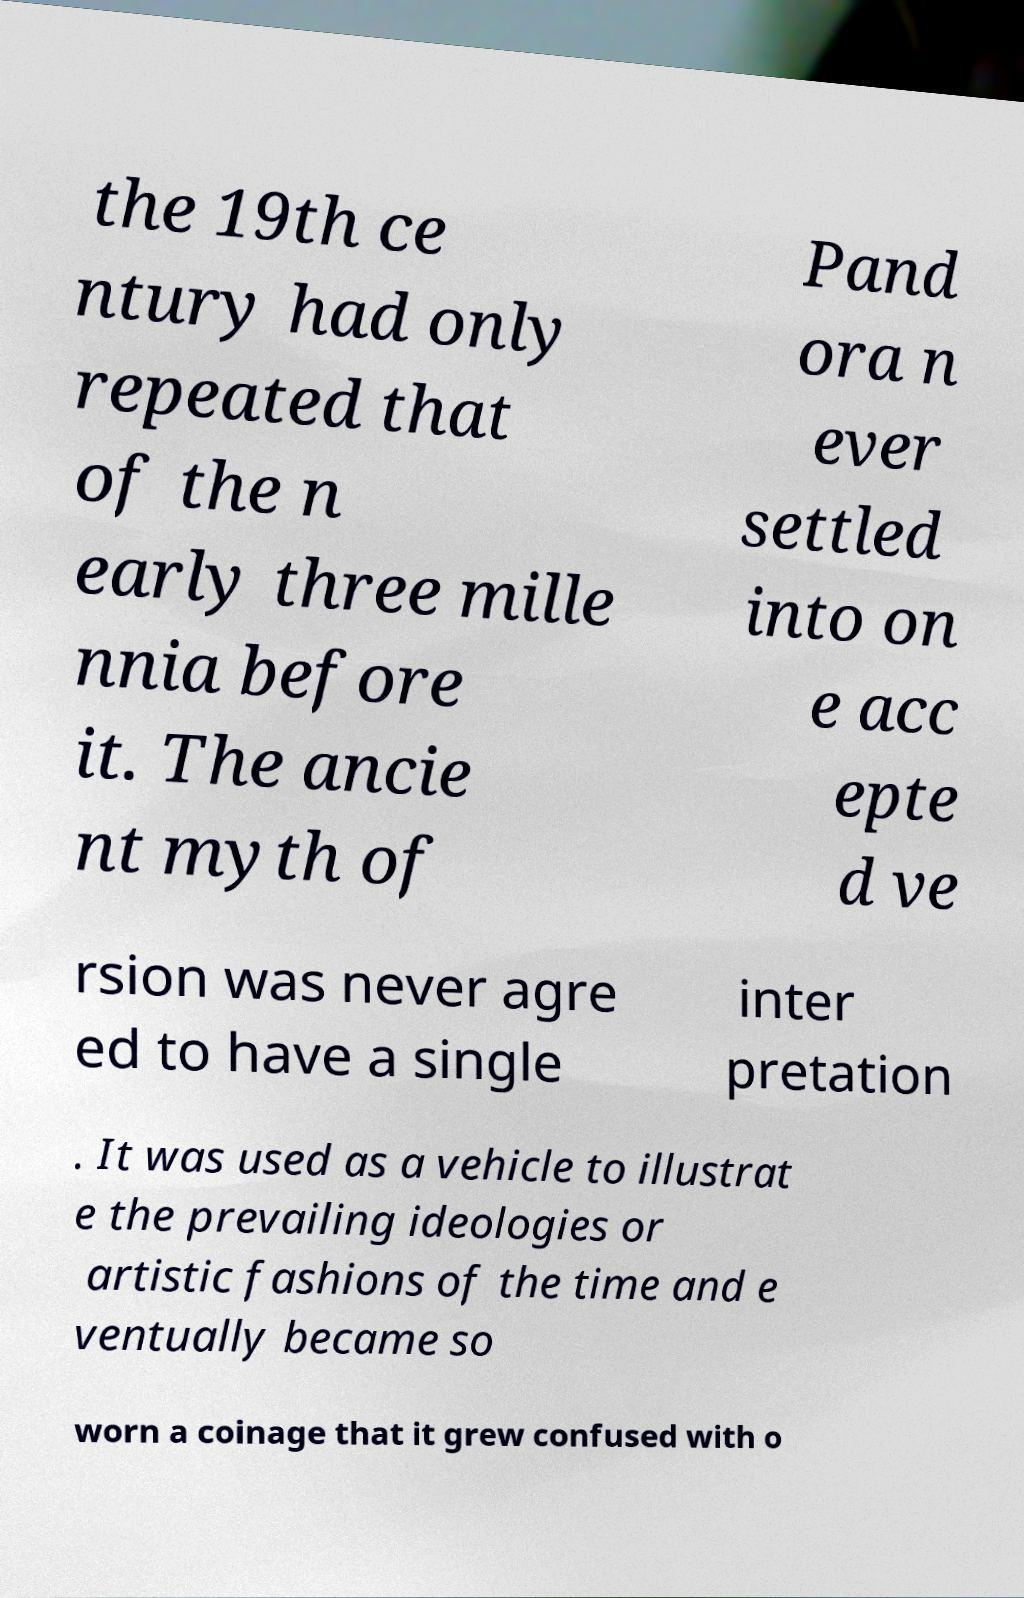There's text embedded in this image that I need extracted. Can you transcribe it verbatim? the 19th ce ntury had only repeated that of the n early three mille nnia before it. The ancie nt myth of Pand ora n ever settled into on e acc epte d ve rsion was never agre ed to have a single inter pretation . It was used as a vehicle to illustrat e the prevailing ideologies or artistic fashions of the time and e ventually became so worn a coinage that it grew confused with o 